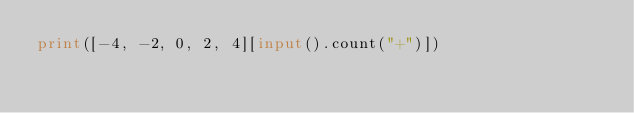Convert code to text. <code><loc_0><loc_0><loc_500><loc_500><_Python_>print([-4, -2, 0, 2, 4][input().count("+")])</code> 